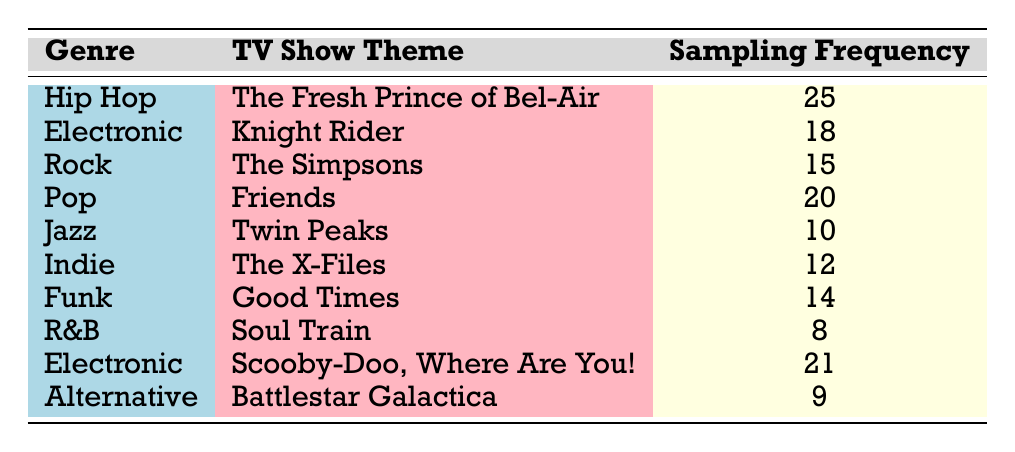What is the sampling frequency of "The Fresh Prince of Bel-Air"? By looking at the row for "The Fresh Prince of Bel-Air" under the genre "Hip Hop," we see that the sampling frequency is listed as 25.
Answer: 25 Which TV show theme has the highest sampling frequency? Among all the entries in the table, "The Fresh Prince of Bel-Air" has the highest sampling frequency of 25.
Answer: The Fresh Prince of Bel-Air How many times is the genre "Electronic" represented in the table? There are two entries for "Electronic" - one for "Knight Rider" with a sampling frequency of 18 and another for "Scooby-Doo, Where Are You!" with a frequency of 21.
Answer: 2 What is the average sampling frequency of all the shows listed? Adding the sampling frequencies: 25 + 18 + 15 + 20 + 10 + 12 + 14 + 8 + 21 + 9 =  152. There are 10 shows, so the average is 152 / 10 = 15.2.
Answer: 15.2 Do any themes from the genre "Funk" have a sampling frequency above 10? Checking the entry for the genre "Funk," we see "Good Times" has a sampling frequency of 14, which is above 10.
Answer: Yes What is the difference in sampling frequency between the highest and lowest values? The highest sampling frequency is 25 (from "The Fresh Prince of Bel-Air") and the lowest is 8 (from "Soul Train"). Therefore, the difference is 25 - 8 = 17.
Answer: 17 Which genre has the lowest sampling frequency? The genre "R&B" has the lowest sampling frequency with a value of 8, as seen in the table.
Answer: R&B Is "Friends" the only show in the "Pop" genre? The table only lists "Friends" under the "Pop" genre, showing that it is indeed the only show in that category.
Answer: Yes What two genres together have an average sampling frequency greater than 15? Considering the genres "Hip Hop" (25) and "Pop" (20), we get the average: (25 + 20) / 2 = 22.5, which is greater than 15.
Answer: Yes 